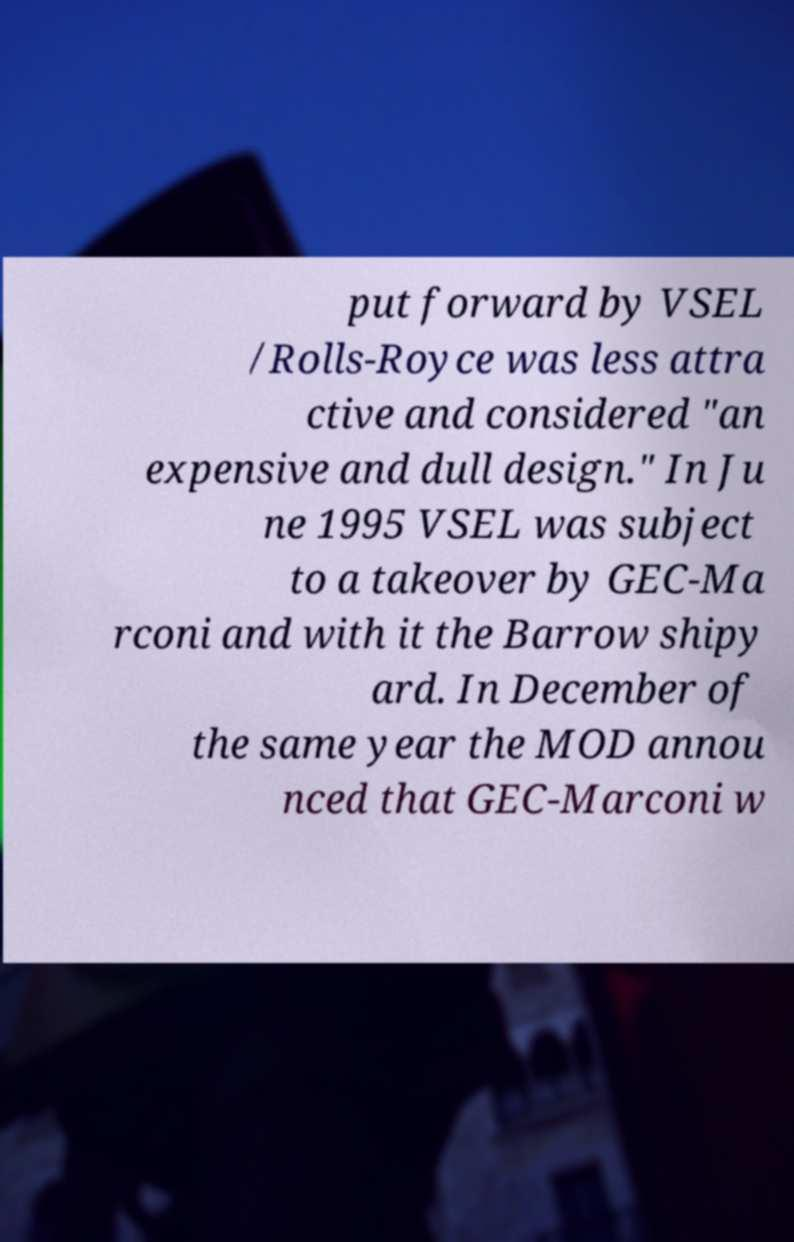I need the written content from this picture converted into text. Can you do that? put forward by VSEL /Rolls-Royce was less attra ctive and considered "an expensive and dull design." In Ju ne 1995 VSEL was subject to a takeover by GEC-Ma rconi and with it the Barrow shipy ard. In December of the same year the MOD annou nced that GEC-Marconi w 